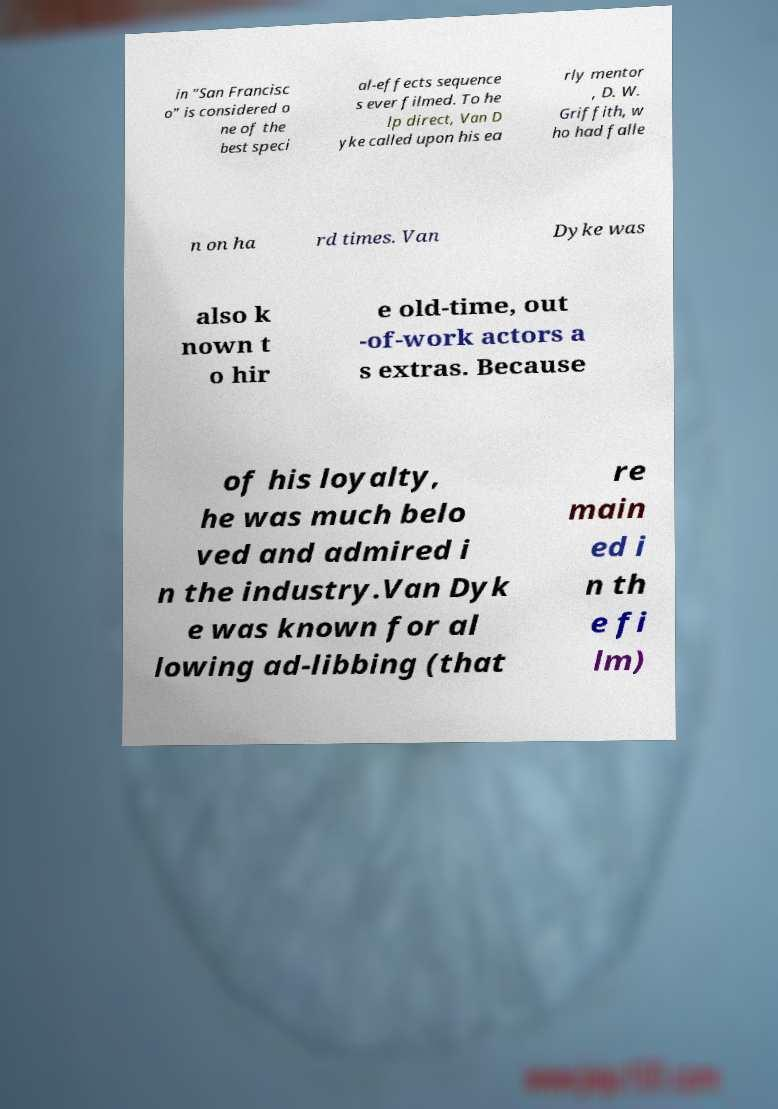Can you read and provide the text displayed in the image?This photo seems to have some interesting text. Can you extract and type it out for me? in "San Francisc o" is considered o ne of the best speci al-effects sequence s ever filmed. To he lp direct, Van D yke called upon his ea rly mentor , D. W. Griffith, w ho had falle n on ha rd times. Van Dyke was also k nown t o hir e old-time, out -of-work actors a s extras. Because of his loyalty, he was much belo ved and admired i n the industry.Van Dyk e was known for al lowing ad-libbing (that re main ed i n th e fi lm) 